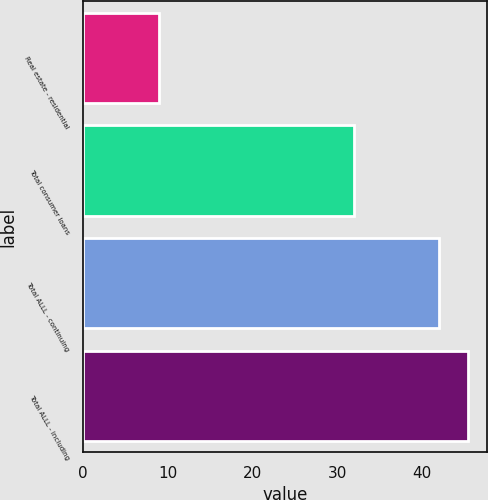Convert chart. <chart><loc_0><loc_0><loc_500><loc_500><bar_chart><fcel>Real estate - residential<fcel>Total consumer loans<fcel>Total ALLL - continuing<fcel>Total ALLL - including<nl><fcel>9<fcel>32<fcel>42<fcel>45.4<nl></chart> 